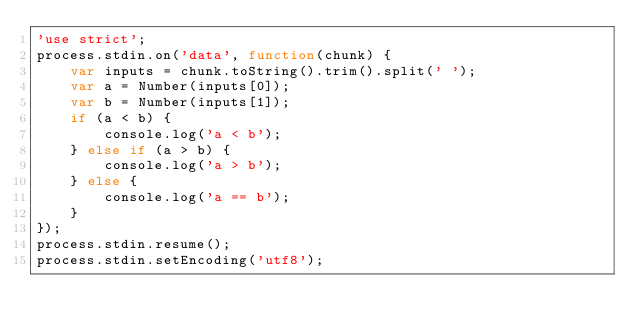<code> <loc_0><loc_0><loc_500><loc_500><_JavaScript_>'use strict';
process.stdin.on('data', function(chunk) {
    var inputs = chunk.toString().trim().split(' ');
    var a = Number(inputs[0]);
    var b = Number(inputs[1]);
    if (a < b) {
        console.log('a < b');
    } else if (a > b) {
        console.log('a > b');
    } else {
        console.log('a == b');
    }
});
process.stdin.resume();
process.stdin.setEncoding('utf8');</code> 